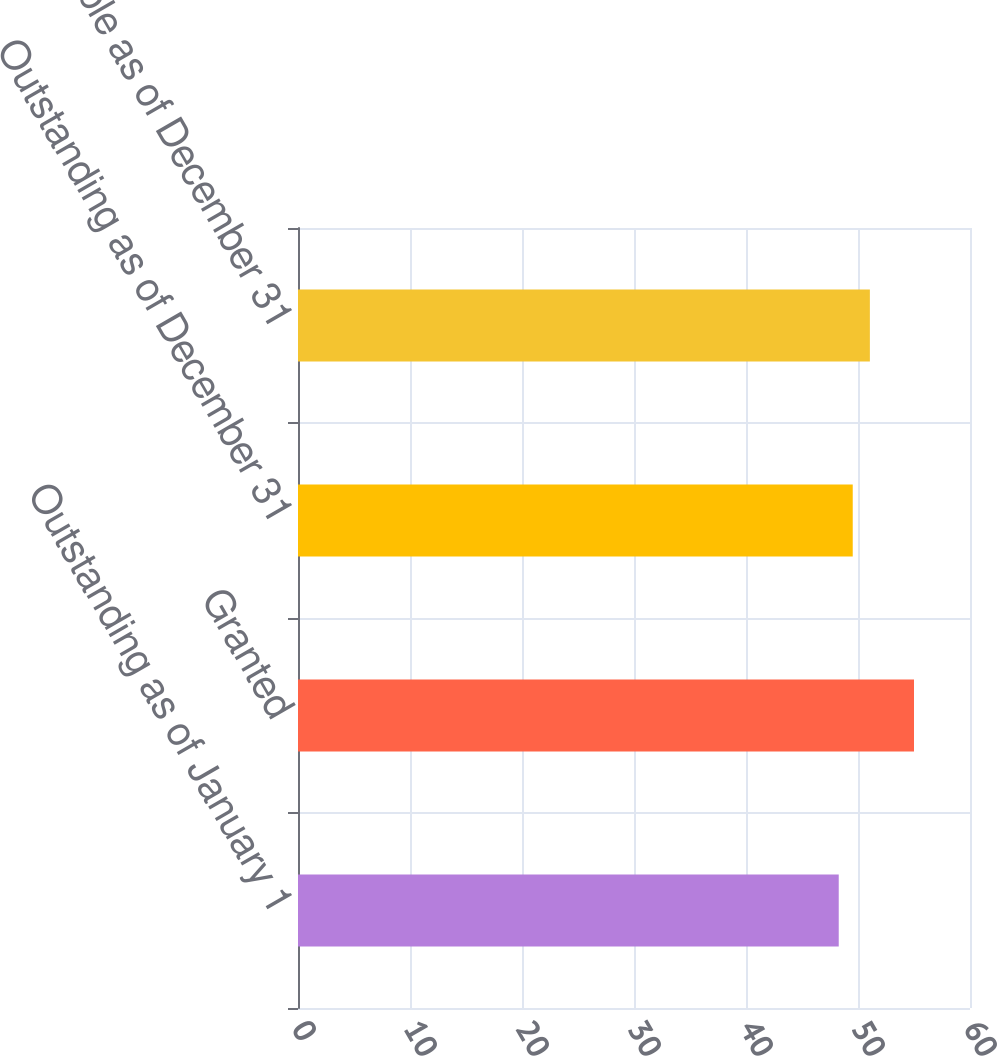Convert chart. <chart><loc_0><loc_0><loc_500><loc_500><bar_chart><fcel>Outstanding as of January 1<fcel>Granted<fcel>Outstanding as of December 31<fcel>Exercisable as of December 31<nl><fcel>48.28<fcel>55<fcel>49.53<fcel>51.06<nl></chart> 